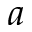<formula> <loc_0><loc_0><loc_500><loc_500>a</formula> 